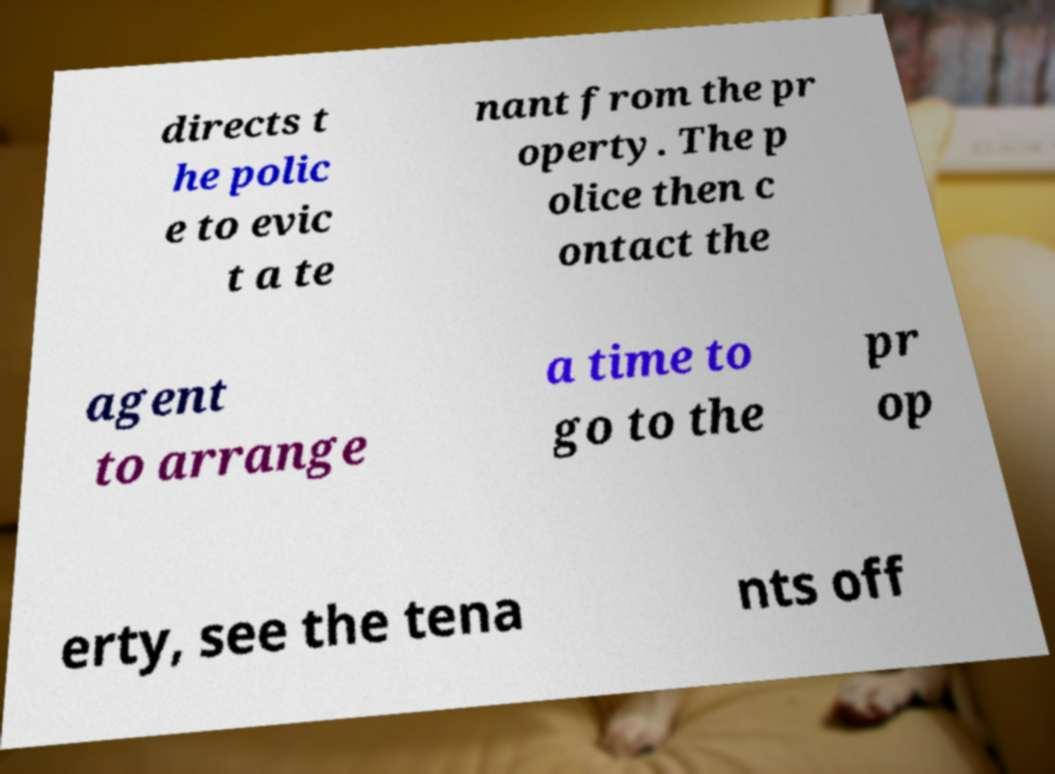Can you read and provide the text displayed in the image?This photo seems to have some interesting text. Can you extract and type it out for me? directs t he polic e to evic t a te nant from the pr operty. The p olice then c ontact the agent to arrange a time to go to the pr op erty, see the tena nts off 